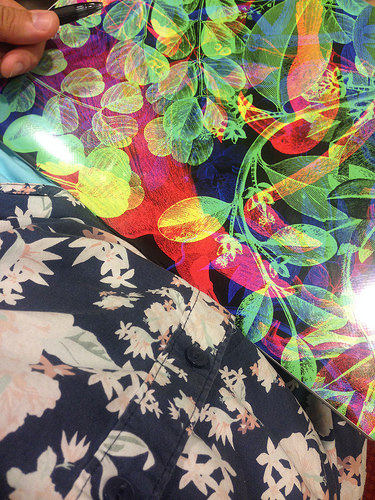<image>
Is there a picture above the shirt? No. The picture is not positioned above the shirt. The vertical arrangement shows a different relationship. 